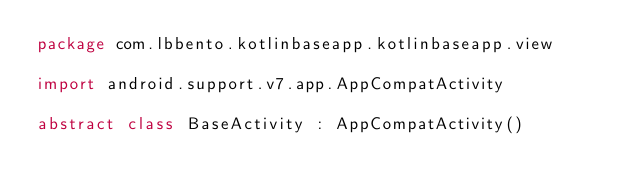Convert code to text. <code><loc_0><loc_0><loc_500><loc_500><_Kotlin_>package com.lbbento.kotlinbaseapp.kotlinbaseapp.view

import android.support.v7.app.AppCompatActivity

abstract class BaseActivity : AppCompatActivity()</code> 